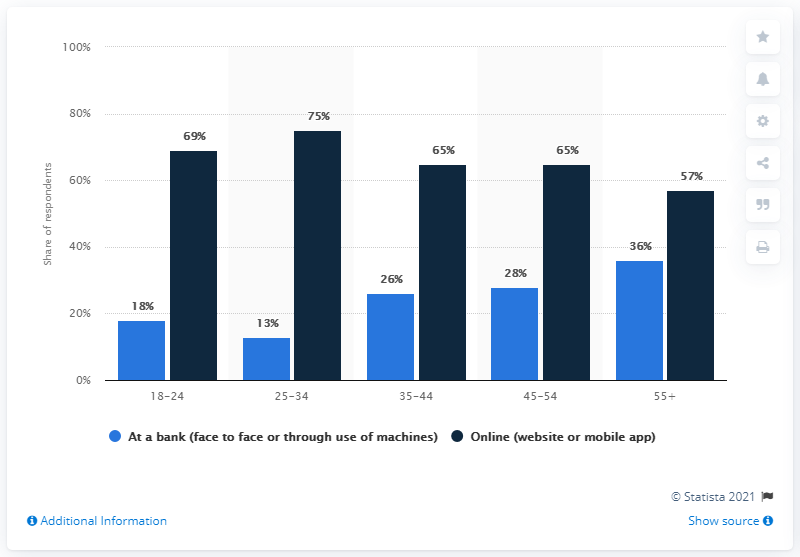Give some essential details in this illustration. The sum of the highest two values is 144. The age category with the smallest difference between the two factors is 55. 